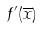Convert formula to latex. <formula><loc_0><loc_0><loc_500><loc_500>f ^ { \prime } ( \overline { x } )</formula> 